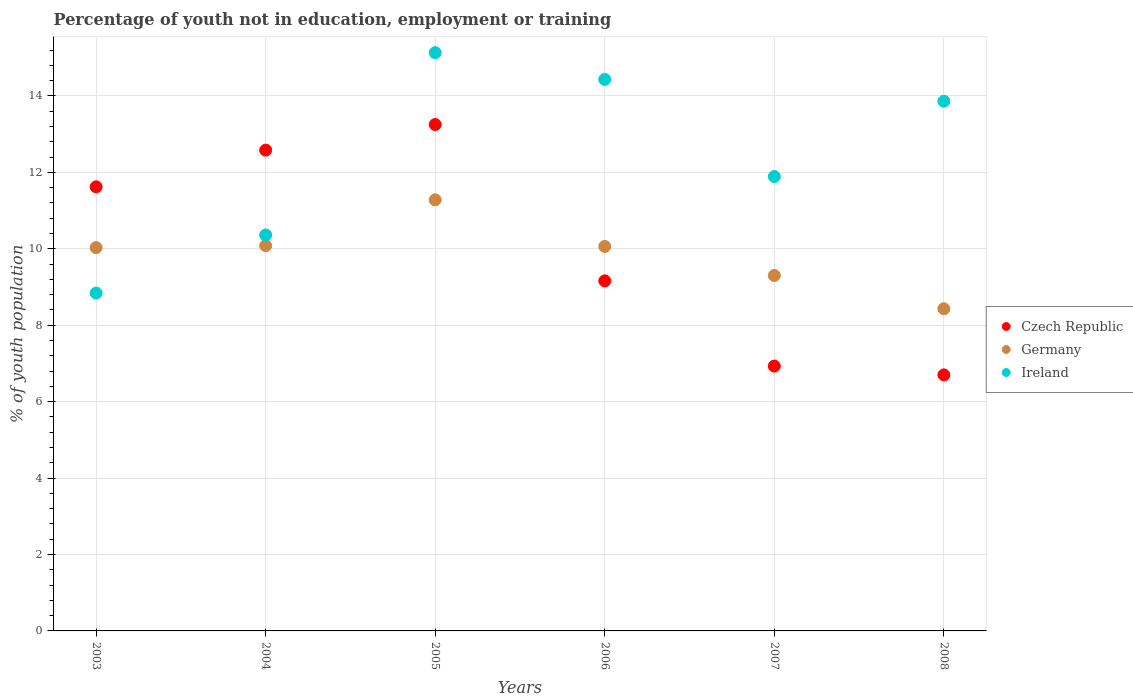Is the number of dotlines equal to the number of legend labels?
Make the answer very short. Yes. What is the percentage of unemployed youth population in in Germany in 2007?
Provide a succinct answer. 9.3. Across all years, what is the maximum percentage of unemployed youth population in in Ireland?
Offer a very short reply. 15.13. Across all years, what is the minimum percentage of unemployed youth population in in Ireland?
Provide a short and direct response. 8.84. What is the total percentage of unemployed youth population in in Ireland in the graph?
Make the answer very short. 74.51. What is the difference between the percentage of unemployed youth population in in Czech Republic in 2005 and that in 2008?
Your answer should be compact. 6.55. What is the difference between the percentage of unemployed youth population in in Ireland in 2005 and the percentage of unemployed youth population in in Germany in 2007?
Offer a terse response. 5.83. What is the average percentage of unemployed youth population in in Germany per year?
Provide a short and direct response. 9.86. In the year 2003, what is the difference between the percentage of unemployed youth population in in Czech Republic and percentage of unemployed youth population in in Germany?
Your response must be concise. 1.59. What is the ratio of the percentage of unemployed youth population in in Germany in 2003 to that in 2005?
Your answer should be compact. 0.89. Is the percentage of unemployed youth population in in Czech Republic in 2004 less than that in 2008?
Keep it short and to the point. No. What is the difference between the highest and the second highest percentage of unemployed youth population in in Ireland?
Offer a terse response. 0.7. What is the difference between the highest and the lowest percentage of unemployed youth population in in Germany?
Ensure brevity in your answer.  2.85. In how many years, is the percentage of unemployed youth population in in Ireland greater than the average percentage of unemployed youth population in in Ireland taken over all years?
Give a very brief answer. 3. Is it the case that in every year, the sum of the percentage of unemployed youth population in in Czech Republic and percentage of unemployed youth population in in Germany  is greater than the percentage of unemployed youth population in in Ireland?
Your answer should be very brief. Yes. Does the percentage of unemployed youth population in in Germany monotonically increase over the years?
Provide a succinct answer. No. Is the percentage of unemployed youth population in in Germany strictly greater than the percentage of unemployed youth population in in Ireland over the years?
Your answer should be compact. No. How many dotlines are there?
Keep it short and to the point. 3. How many years are there in the graph?
Provide a short and direct response. 6. What is the difference between two consecutive major ticks on the Y-axis?
Make the answer very short. 2. Are the values on the major ticks of Y-axis written in scientific E-notation?
Your response must be concise. No. Does the graph contain any zero values?
Keep it short and to the point. No. Does the graph contain grids?
Give a very brief answer. Yes. Where does the legend appear in the graph?
Your answer should be very brief. Center right. How many legend labels are there?
Your response must be concise. 3. How are the legend labels stacked?
Your answer should be very brief. Vertical. What is the title of the graph?
Provide a short and direct response. Percentage of youth not in education, employment or training. What is the label or title of the Y-axis?
Offer a very short reply. % of youth population. What is the % of youth population in Czech Republic in 2003?
Give a very brief answer. 11.62. What is the % of youth population in Germany in 2003?
Make the answer very short. 10.03. What is the % of youth population in Ireland in 2003?
Keep it short and to the point. 8.84. What is the % of youth population of Czech Republic in 2004?
Give a very brief answer. 12.58. What is the % of youth population of Germany in 2004?
Offer a terse response. 10.08. What is the % of youth population in Ireland in 2004?
Provide a short and direct response. 10.36. What is the % of youth population of Czech Republic in 2005?
Make the answer very short. 13.25. What is the % of youth population of Germany in 2005?
Your answer should be compact. 11.28. What is the % of youth population of Ireland in 2005?
Provide a succinct answer. 15.13. What is the % of youth population of Czech Republic in 2006?
Your answer should be compact. 9.16. What is the % of youth population in Germany in 2006?
Give a very brief answer. 10.06. What is the % of youth population of Ireland in 2006?
Make the answer very short. 14.43. What is the % of youth population of Czech Republic in 2007?
Keep it short and to the point. 6.93. What is the % of youth population of Germany in 2007?
Your answer should be compact. 9.3. What is the % of youth population in Ireland in 2007?
Provide a short and direct response. 11.89. What is the % of youth population of Czech Republic in 2008?
Your answer should be compact. 6.7. What is the % of youth population of Germany in 2008?
Your answer should be very brief. 8.43. What is the % of youth population of Ireland in 2008?
Ensure brevity in your answer.  13.86. Across all years, what is the maximum % of youth population in Czech Republic?
Ensure brevity in your answer.  13.25. Across all years, what is the maximum % of youth population in Germany?
Your answer should be very brief. 11.28. Across all years, what is the maximum % of youth population of Ireland?
Your response must be concise. 15.13. Across all years, what is the minimum % of youth population of Czech Republic?
Provide a succinct answer. 6.7. Across all years, what is the minimum % of youth population of Germany?
Keep it short and to the point. 8.43. Across all years, what is the minimum % of youth population of Ireland?
Offer a terse response. 8.84. What is the total % of youth population in Czech Republic in the graph?
Offer a terse response. 60.24. What is the total % of youth population in Germany in the graph?
Your answer should be very brief. 59.18. What is the total % of youth population of Ireland in the graph?
Your answer should be compact. 74.51. What is the difference between the % of youth population in Czech Republic in 2003 and that in 2004?
Provide a succinct answer. -0.96. What is the difference between the % of youth population of Germany in 2003 and that in 2004?
Ensure brevity in your answer.  -0.05. What is the difference between the % of youth population in Ireland in 2003 and that in 2004?
Your response must be concise. -1.52. What is the difference between the % of youth population in Czech Republic in 2003 and that in 2005?
Your answer should be compact. -1.63. What is the difference between the % of youth population in Germany in 2003 and that in 2005?
Give a very brief answer. -1.25. What is the difference between the % of youth population of Ireland in 2003 and that in 2005?
Your answer should be compact. -6.29. What is the difference between the % of youth population of Czech Republic in 2003 and that in 2006?
Your response must be concise. 2.46. What is the difference between the % of youth population in Germany in 2003 and that in 2006?
Your response must be concise. -0.03. What is the difference between the % of youth population of Ireland in 2003 and that in 2006?
Provide a succinct answer. -5.59. What is the difference between the % of youth population in Czech Republic in 2003 and that in 2007?
Your answer should be very brief. 4.69. What is the difference between the % of youth population in Germany in 2003 and that in 2007?
Your response must be concise. 0.73. What is the difference between the % of youth population in Ireland in 2003 and that in 2007?
Your response must be concise. -3.05. What is the difference between the % of youth population in Czech Republic in 2003 and that in 2008?
Offer a terse response. 4.92. What is the difference between the % of youth population in Germany in 2003 and that in 2008?
Offer a terse response. 1.6. What is the difference between the % of youth population of Ireland in 2003 and that in 2008?
Keep it short and to the point. -5.02. What is the difference between the % of youth population in Czech Republic in 2004 and that in 2005?
Your response must be concise. -0.67. What is the difference between the % of youth population of Ireland in 2004 and that in 2005?
Your answer should be very brief. -4.77. What is the difference between the % of youth population of Czech Republic in 2004 and that in 2006?
Offer a very short reply. 3.42. What is the difference between the % of youth population of Germany in 2004 and that in 2006?
Offer a terse response. 0.02. What is the difference between the % of youth population of Ireland in 2004 and that in 2006?
Give a very brief answer. -4.07. What is the difference between the % of youth population in Czech Republic in 2004 and that in 2007?
Your answer should be compact. 5.65. What is the difference between the % of youth population in Germany in 2004 and that in 2007?
Keep it short and to the point. 0.78. What is the difference between the % of youth population of Ireland in 2004 and that in 2007?
Make the answer very short. -1.53. What is the difference between the % of youth population of Czech Republic in 2004 and that in 2008?
Keep it short and to the point. 5.88. What is the difference between the % of youth population in Germany in 2004 and that in 2008?
Make the answer very short. 1.65. What is the difference between the % of youth population in Czech Republic in 2005 and that in 2006?
Ensure brevity in your answer.  4.09. What is the difference between the % of youth population of Germany in 2005 and that in 2006?
Provide a short and direct response. 1.22. What is the difference between the % of youth population of Ireland in 2005 and that in 2006?
Keep it short and to the point. 0.7. What is the difference between the % of youth population of Czech Republic in 2005 and that in 2007?
Provide a succinct answer. 6.32. What is the difference between the % of youth population of Germany in 2005 and that in 2007?
Your answer should be compact. 1.98. What is the difference between the % of youth population in Ireland in 2005 and that in 2007?
Give a very brief answer. 3.24. What is the difference between the % of youth population of Czech Republic in 2005 and that in 2008?
Ensure brevity in your answer.  6.55. What is the difference between the % of youth population in Germany in 2005 and that in 2008?
Give a very brief answer. 2.85. What is the difference between the % of youth population of Ireland in 2005 and that in 2008?
Your response must be concise. 1.27. What is the difference between the % of youth population of Czech Republic in 2006 and that in 2007?
Provide a short and direct response. 2.23. What is the difference between the % of youth population of Germany in 2006 and that in 2007?
Provide a short and direct response. 0.76. What is the difference between the % of youth population of Ireland in 2006 and that in 2007?
Offer a terse response. 2.54. What is the difference between the % of youth population in Czech Republic in 2006 and that in 2008?
Give a very brief answer. 2.46. What is the difference between the % of youth population of Germany in 2006 and that in 2008?
Your answer should be very brief. 1.63. What is the difference between the % of youth population in Ireland in 2006 and that in 2008?
Your answer should be very brief. 0.57. What is the difference between the % of youth population in Czech Republic in 2007 and that in 2008?
Provide a short and direct response. 0.23. What is the difference between the % of youth population in Germany in 2007 and that in 2008?
Offer a very short reply. 0.87. What is the difference between the % of youth population in Ireland in 2007 and that in 2008?
Your answer should be compact. -1.97. What is the difference between the % of youth population in Czech Republic in 2003 and the % of youth population in Germany in 2004?
Your answer should be very brief. 1.54. What is the difference between the % of youth population in Czech Republic in 2003 and the % of youth population in Ireland in 2004?
Your answer should be very brief. 1.26. What is the difference between the % of youth population in Germany in 2003 and the % of youth population in Ireland in 2004?
Provide a succinct answer. -0.33. What is the difference between the % of youth population in Czech Republic in 2003 and the % of youth population in Germany in 2005?
Keep it short and to the point. 0.34. What is the difference between the % of youth population in Czech Republic in 2003 and the % of youth population in Ireland in 2005?
Provide a succinct answer. -3.51. What is the difference between the % of youth population in Czech Republic in 2003 and the % of youth population in Germany in 2006?
Your response must be concise. 1.56. What is the difference between the % of youth population in Czech Republic in 2003 and the % of youth population in Ireland in 2006?
Offer a very short reply. -2.81. What is the difference between the % of youth population of Germany in 2003 and the % of youth population of Ireland in 2006?
Give a very brief answer. -4.4. What is the difference between the % of youth population in Czech Republic in 2003 and the % of youth population in Germany in 2007?
Provide a short and direct response. 2.32. What is the difference between the % of youth population of Czech Republic in 2003 and the % of youth population of Ireland in 2007?
Offer a very short reply. -0.27. What is the difference between the % of youth population of Germany in 2003 and the % of youth population of Ireland in 2007?
Make the answer very short. -1.86. What is the difference between the % of youth population of Czech Republic in 2003 and the % of youth population of Germany in 2008?
Give a very brief answer. 3.19. What is the difference between the % of youth population in Czech Republic in 2003 and the % of youth population in Ireland in 2008?
Give a very brief answer. -2.24. What is the difference between the % of youth population of Germany in 2003 and the % of youth population of Ireland in 2008?
Make the answer very short. -3.83. What is the difference between the % of youth population of Czech Republic in 2004 and the % of youth population of Germany in 2005?
Keep it short and to the point. 1.3. What is the difference between the % of youth population of Czech Republic in 2004 and the % of youth population of Ireland in 2005?
Your answer should be very brief. -2.55. What is the difference between the % of youth population of Germany in 2004 and the % of youth population of Ireland in 2005?
Ensure brevity in your answer.  -5.05. What is the difference between the % of youth population of Czech Republic in 2004 and the % of youth population of Germany in 2006?
Your response must be concise. 2.52. What is the difference between the % of youth population in Czech Republic in 2004 and the % of youth population in Ireland in 2006?
Your answer should be very brief. -1.85. What is the difference between the % of youth population in Germany in 2004 and the % of youth population in Ireland in 2006?
Offer a terse response. -4.35. What is the difference between the % of youth population in Czech Republic in 2004 and the % of youth population in Germany in 2007?
Offer a very short reply. 3.28. What is the difference between the % of youth population in Czech Republic in 2004 and the % of youth population in Ireland in 2007?
Give a very brief answer. 0.69. What is the difference between the % of youth population of Germany in 2004 and the % of youth population of Ireland in 2007?
Your answer should be compact. -1.81. What is the difference between the % of youth population of Czech Republic in 2004 and the % of youth population of Germany in 2008?
Offer a very short reply. 4.15. What is the difference between the % of youth population of Czech Republic in 2004 and the % of youth population of Ireland in 2008?
Your answer should be very brief. -1.28. What is the difference between the % of youth population in Germany in 2004 and the % of youth population in Ireland in 2008?
Your answer should be very brief. -3.78. What is the difference between the % of youth population of Czech Republic in 2005 and the % of youth population of Germany in 2006?
Your answer should be compact. 3.19. What is the difference between the % of youth population in Czech Republic in 2005 and the % of youth population in Ireland in 2006?
Your response must be concise. -1.18. What is the difference between the % of youth population in Germany in 2005 and the % of youth population in Ireland in 2006?
Offer a very short reply. -3.15. What is the difference between the % of youth population in Czech Republic in 2005 and the % of youth population in Germany in 2007?
Make the answer very short. 3.95. What is the difference between the % of youth population in Czech Republic in 2005 and the % of youth population in Ireland in 2007?
Offer a very short reply. 1.36. What is the difference between the % of youth population of Germany in 2005 and the % of youth population of Ireland in 2007?
Keep it short and to the point. -0.61. What is the difference between the % of youth population of Czech Republic in 2005 and the % of youth population of Germany in 2008?
Make the answer very short. 4.82. What is the difference between the % of youth population in Czech Republic in 2005 and the % of youth population in Ireland in 2008?
Keep it short and to the point. -0.61. What is the difference between the % of youth population of Germany in 2005 and the % of youth population of Ireland in 2008?
Make the answer very short. -2.58. What is the difference between the % of youth population in Czech Republic in 2006 and the % of youth population in Germany in 2007?
Provide a succinct answer. -0.14. What is the difference between the % of youth population in Czech Republic in 2006 and the % of youth population in Ireland in 2007?
Keep it short and to the point. -2.73. What is the difference between the % of youth population in Germany in 2006 and the % of youth population in Ireland in 2007?
Give a very brief answer. -1.83. What is the difference between the % of youth population in Czech Republic in 2006 and the % of youth population in Germany in 2008?
Your answer should be compact. 0.73. What is the difference between the % of youth population in Czech Republic in 2006 and the % of youth population in Ireland in 2008?
Give a very brief answer. -4.7. What is the difference between the % of youth population in Czech Republic in 2007 and the % of youth population in Germany in 2008?
Offer a very short reply. -1.5. What is the difference between the % of youth population of Czech Republic in 2007 and the % of youth population of Ireland in 2008?
Ensure brevity in your answer.  -6.93. What is the difference between the % of youth population in Germany in 2007 and the % of youth population in Ireland in 2008?
Your answer should be compact. -4.56. What is the average % of youth population in Czech Republic per year?
Offer a very short reply. 10.04. What is the average % of youth population in Germany per year?
Your response must be concise. 9.86. What is the average % of youth population of Ireland per year?
Keep it short and to the point. 12.42. In the year 2003, what is the difference between the % of youth population in Czech Republic and % of youth population in Germany?
Your answer should be compact. 1.59. In the year 2003, what is the difference between the % of youth population in Czech Republic and % of youth population in Ireland?
Keep it short and to the point. 2.78. In the year 2003, what is the difference between the % of youth population of Germany and % of youth population of Ireland?
Your answer should be very brief. 1.19. In the year 2004, what is the difference between the % of youth population of Czech Republic and % of youth population of Germany?
Offer a terse response. 2.5. In the year 2004, what is the difference between the % of youth population of Czech Republic and % of youth population of Ireland?
Make the answer very short. 2.22. In the year 2004, what is the difference between the % of youth population in Germany and % of youth population in Ireland?
Your answer should be compact. -0.28. In the year 2005, what is the difference between the % of youth population of Czech Republic and % of youth population of Germany?
Offer a very short reply. 1.97. In the year 2005, what is the difference between the % of youth population of Czech Republic and % of youth population of Ireland?
Provide a short and direct response. -1.88. In the year 2005, what is the difference between the % of youth population in Germany and % of youth population in Ireland?
Provide a succinct answer. -3.85. In the year 2006, what is the difference between the % of youth population of Czech Republic and % of youth population of Ireland?
Offer a very short reply. -5.27. In the year 2006, what is the difference between the % of youth population in Germany and % of youth population in Ireland?
Offer a very short reply. -4.37. In the year 2007, what is the difference between the % of youth population of Czech Republic and % of youth population of Germany?
Your response must be concise. -2.37. In the year 2007, what is the difference between the % of youth population of Czech Republic and % of youth population of Ireland?
Your answer should be very brief. -4.96. In the year 2007, what is the difference between the % of youth population of Germany and % of youth population of Ireland?
Provide a succinct answer. -2.59. In the year 2008, what is the difference between the % of youth population in Czech Republic and % of youth population in Germany?
Provide a succinct answer. -1.73. In the year 2008, what is the difference between the % of youth population of Czech Republic and % of youth population of Ireland?
Your response must be concise. -7.16. In the year 2008, what is the difference between the % of youth population of Germany and % of youth population of Ireland?
Keep it short and to the point. -5.43. What is the ratio of the % of youth population of Czech Republic in 2003 to that in 2004?
Your answer should be compact. 0.92. What is the ratio of the % of youth population in Germany in 2003 to that in 2004?
Provide a short and direct response. 0.99. What is the ratio of the % of youth population in Ireland in 2003 to that in 2004?
Give a very brief answer. 0.85. What is the ratio of the % of youth population in Czech Republic in 2003 to that in 2005?
Offer a terse response. 0.88. What is the ratio of the % of youth population in Germany in 2003 to that in 2005?
Your answer should be compact. 0.89. What is the ratio of the % of youth population in Ireland in 2003 to that in 2005?
Your answer should be compact. 0.58. What is the ratio of the % of youth population of Czech Republic in 2003 to that in 2006?
Provide a succinct answer. 1.27. What is the ratio of the % of youth population in Ireland in 2003 to that in 2006?
Ensure brevity in your answer.  0.61. What is the ratio of the % of youth population in Czech Republic in 2003 to that in 2007?
Provide a short and direct response. 1.68. What is the ratio of the % of youth population in Germany in 2003 to that in 2007?
Your response must be concise. 1.08. What is the ratio of the % of youth population of Ireland in 2003 to that in 2007?
Your answer should be very brief. 0.74. What is the ratio of the % of youth population of Czech Republic in 2003 to that in 2008?
Make the answer very short. 1.73. What is the ratio of the % of youth population of Germany in 2003 to that in 2008?
Offer a very short reply. 1.19. What is the ratio of the % of youth population of Ireland in 2003 to that in 2008?
Your response must be concise. 0.64. What is the ratio of the % of youth population of Czech Republic in 2004 to that in 2005?
Provide a short and direct response. 0.95. What is the ratio of the % of youth population of Germany in 2004 to that in 2005?
Your answer should be very brief. 0.89. What is the ratio of the % of youth population of Ireland in 2004 to that in 2005?
Your response must be concise. 0.68. What is the ratio of the % of youth population of Czech Republic in 2004 to that in 2006?
Offer a terse response. 1.37. What is the ratio of the % of youth population in Germany in 2004 to that in 2006?
Offer a terse response. 1. What is the ratio of the % of youth population of Ireland in 2004 to that in 2006?
Provide a short and direct response. 0.72. What is the ratio of the % of youth population of Czech Republic in 2004 to that in 2007?
Provide a succinct answer. 1.82. What is the ratio of the % of youth population of Germany in 2004 to that in 2007?
Keep it short and to the point. 1.08. What is the ratio of the % of youth population of Ireland in 2004 to that in 2007?
Your answer should be compact. 0.87. What is the ratio of the % of youth population of Czech Republic in 2004 to that in 2008?
Your answer should be very brief. 1.88. What is the ratio of the % of youth population in Germany in 2004 to that in 2008?
Your answer should be compact. 1.2. What is the ratio of the % of youth population of Ireland in 2004 to that in 2008?
Your response must be concise. 0.75. What is the ratio of the % of youth population in Czech Republic in 2005 to that in 2006?
Ensure brevity in your answer.  1.45. What is the ratio of the % of youth population in Germany in 2005 to that in 2006?
Offer a very short reply. 1.12. What is the ratio of the % of youth population in Ireland in 2005 to that in 2006?
Offer a terse response. 1.05. What is the ratio of the % of youth population of Czech Republic in 2005 to that in 2007?
Give a very brief answer. 1.91. What is the ratio of the % of youth population of Germany in 2005 to that in 2007?
Your answer should be compact. 1.21. What is the ratio of the % of youth population of Ireland in 2005 to that in 2007?
Provide a succinct answer. 1.27. What is the ratio of the % of youth population in Czech Republic in 2005 to that in 2008?
Your answer should be very brief. 1.98. What is the ratio of the % of youth population of Germany in 2005 to that in 2008?
Ensure brevity in your answer.  1.34. What is the ratio of the % of youth population in Ireland in 2005 to that in 2008?
Keep it short and to the point. 1.09. What is the ratio of the % of youth population in Czech Republic in 2006 to that in 2007?
Your response must be concise. 1.32. What is the ratio of the % of youth population in Germany in 2006 to that in 2007?
Make the answer very short. 1.08. What is the ratio of the % of youth population of Ireland in 2006 to that in 2007?
Your answer should be very brief. 1.21. What is the ratio of the % of youth population in Czech Republic in 2006 to that in 2008?
Your answer should be compact. 1.37. What is the ratio of the % of youth population of Germany in 2006 to that in 2008?
Offer a terse response. 1.19. What is the ratio of the % of youth population in Ireland in 2006 to that in 2008?
Offer a very short reply. 1.04. What is the ratio of the % of youth population of Czech Republic in 2007 to that in 2008?
Keep it short and to the point. 1.03. What is the ratio of the % of youth population in Germany in 2007 to that in 2008?
Ensure brevity in your answer.  1.1. What is the ratio of the % of youth population in Ireland in 2007 to that in 2008?
Make the answer very short. 0.86. What is the difference between the highest and the second highest % of youth population in Czech Republic?
Offer a very short reply. 0.67. What is the difference between the highest and the second highest % of youth population of Germany?
Ensure brevity in your answer.  1.2. What is the difference between the highest and the lowest % of youth population in Czech Republic?
Your answer should be compact. 6.55. What is the difference between the highest and the lowest % of youth population in Germany?
Your answer should be compact. 2.85. What is the difference between the highest and the lowest % of youth population of Ireland?
Offer a very short reply. 6.29. 